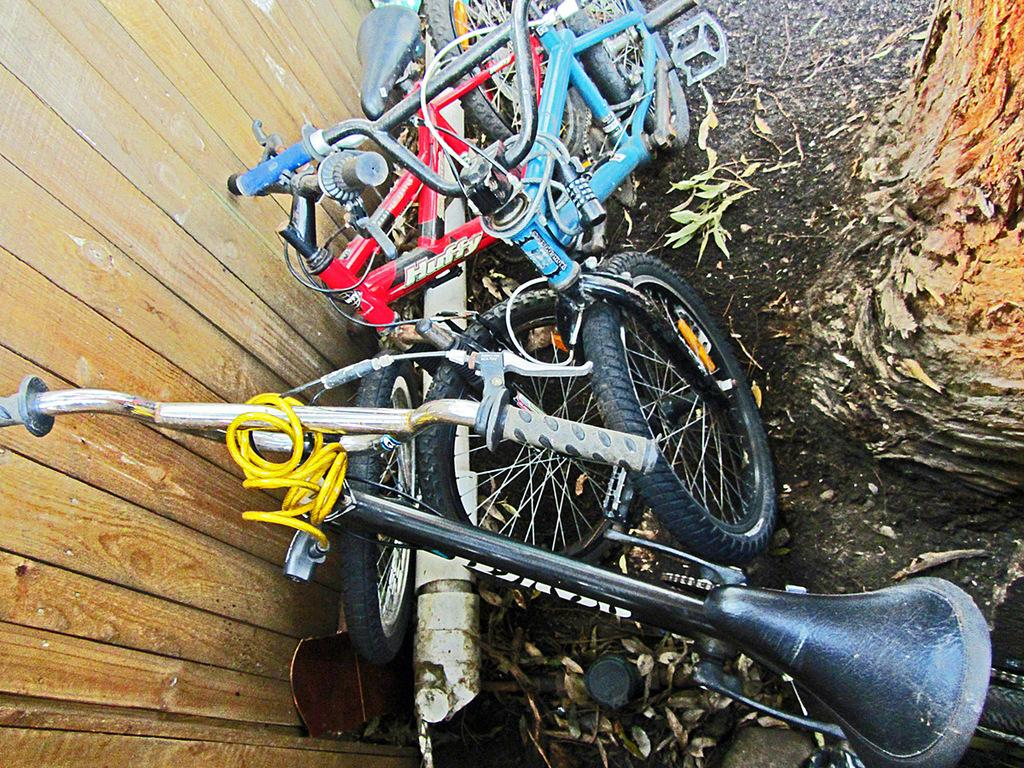What type of vehicles are present in the image? There are many bicycles in the image. Where are the bicycles located? The bicycles are on the land. What can be seen on the left side of the image? There is a wooden fence on the left side of the image. What is present on the right side of the image? There is a tree bark on the right side of the image. How many eggs are being used to support the bicycles in the image? There are no eggs present in the image; the bicycles are on the land. 